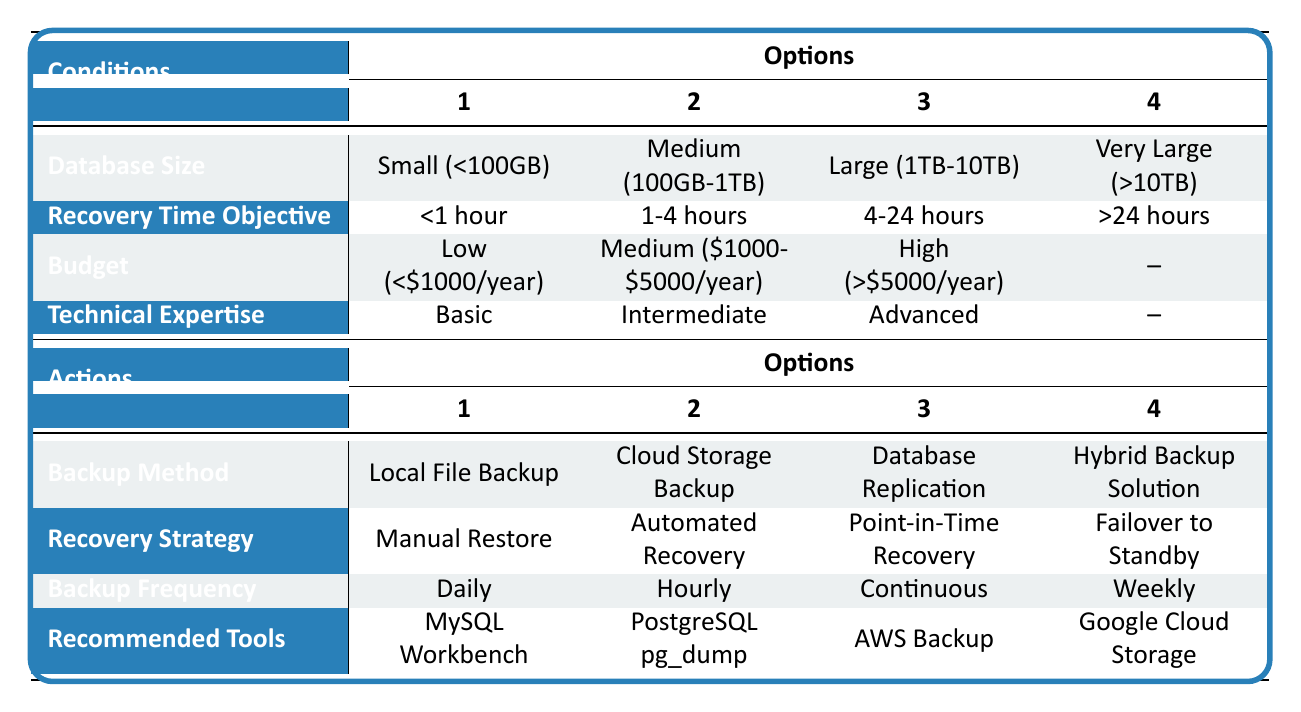What backup method is recommended for a large database with a medium budget? Looking at the table, for a large database (1TB-10TB) and a medium budget ($1000-$5000/year), the suitable backup methods listed are "Cloud Storage Backup" and "Hybrid Backup Solution". These align with both database size and budget constraints.
Answer: Cloud Storage Backup or Hybrid Backup Solution Is the recovery time objective for small databases generally less than one hour? The option listed for small databases is "<1 hour", meaning recovery time is indeed expected to be less than one hour.
Answer: Yes Which backup frequency is recommended for databases requiring automated recovery? The table indicates that "Automated Recovery" does not specify a recommended backup frequency directly. However, for efficient automated processes, "Hourly" or "Continuous" frequencies would be more pertinent to ensure minimal data loss. Further investigation is needed based on specific conditions.
Answer: Hourly or Continuous If a nonprofit has advanced technical expertise and a very large database (>10TB), can they use local file backup? For a very large database and advanced technical expertise, local file backup is not listed as an ideal method due to scalability and potential recovery issues. Therefore, it may not be suitable.
Answer: No What are the recommended tools associated with cloud storage backup for medium database sizes? The table mentions "Cloud Storage Backup" as a method but does not directly relate it to specific tools for medium databases. However, tools like "AWS Backup" or "Google Cloud Storage" could be inferred as suitable for backing up medium-sized databases in a cloud environment.
Answer: AWS Backup or Google Cloud Storage What is the difference in backup frequency recommendations for databases requiring manual restore versus those needing automated recovery? From the table, "Manual Restore" is linked to a frequency of "Weekly", while "Automated Recovery" could be linked to "Hourly" or "Continuous". This suggests that manual processes are less frequent compared to the more continuous needs of an automated strategy.
Answer: Weekly vs Hourly/Continuous Are there any high budget options for backup methods of medium-sized databases? The options for medium-sized databases (100GB-1TB) under a high budget (>5000/year) would include "Enterprise Backup Software", which isn't explicitly tied to a database size but may include features for such databases, indicating a yes.
Answer: Yes What is the relationship between budget size and the level of technical expertise recommended for backup solutions? The table suggests that as budget increases, it may allow for more advanced tools and strategies, indicating that organizations with higher budgets might engage advanced technical expertise. For low budgets, basic expertise is noted. This shows a progressive relationship.
Answer: Higher budget allows for advanced expertise 